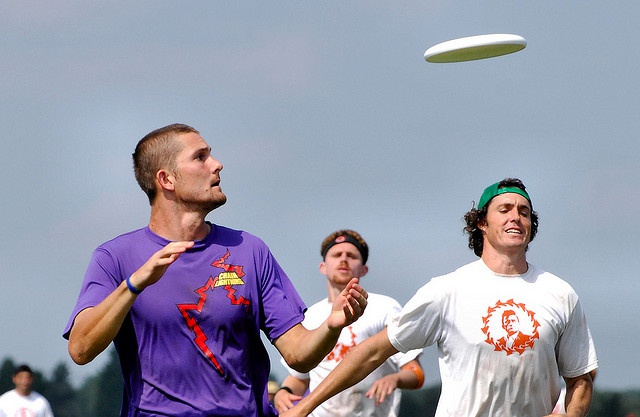Describe the objects in this image and their specific colors. I can see people in darkgray, black, purple, darkblue, and navy tones, people in darkgray, white, gray, and salmon tones, people in darkgray, white, lightpink, and brown tones, frisbee in darkgray, white, and olive tones, and people in darkgray, white, black, brown, and maroon tones in this image. 